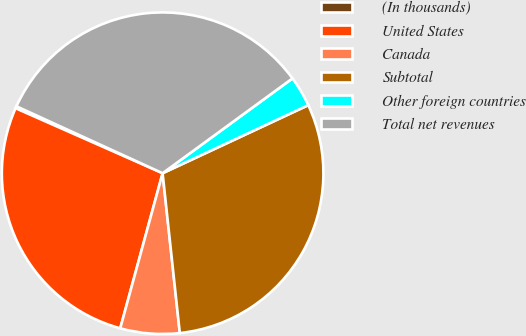Convert chart to OTSL. <chart><loc_0><loc_0><loc_500><loc_500><pie_chart><fcel>(In thousands)<fcel>United States<fcel>Canada<fcel>Subtotal<fcel>Other foreign countries<fcel>Total net revenues<nl><fcel>0.21%<fcel>27.38%<fcel>5.95%<fcel>30.25%<fcel>3.08%<fcel>33.13%<nl></chart> 